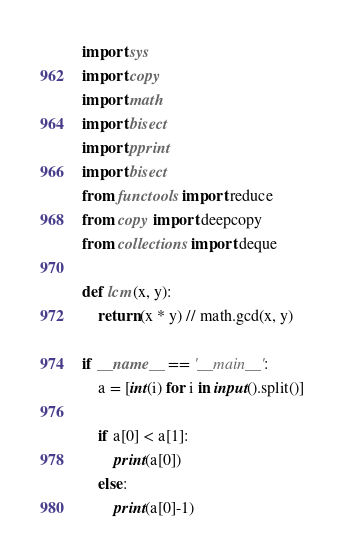Convert code to text. <code><loc_0><loc_0><loc_500><loc_500><_Python_>import sys
import copy
import math
import bisect
import pprint
import bisect
from functools import reduce
from copy import deepcopy
from collections import deque

def lcm(x, y):
    return (x * y) // math.gcd(x, y)

if __name__ == '__main__':
    a = [int(i) for i in input().split()]

    if a[0] < a[1]:
        print(a[0])
    else:
        print(a[0]-1)</code> 